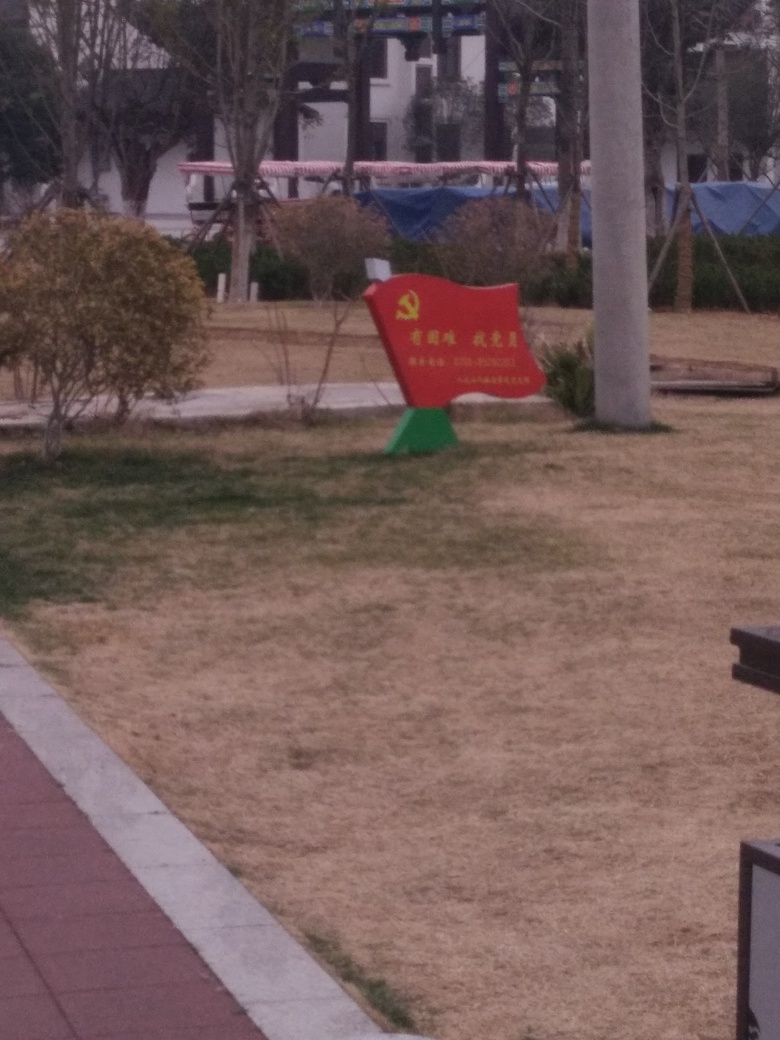What might be the purpose of the red bench in this image? The red bench serves a dual purpose; it functions as a seat for visitors to rest and as a marker or memorial given its prominent color and emblem. It likely holds significance to the community or the space where it is installed. 